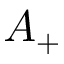<formula> <loc_0><loc_0><loc_500><loc_500>A _ { + }</formula> 